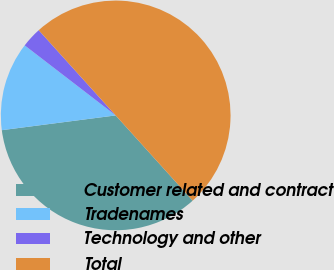Convert chart. <chart><loc_0><loc_0><loc_500><loc_500><pie_chart><fcel>Customer related and contract<fcel>Tradenames<fcel>Technology and other<fcel>Total<nl><fcel>34.64%<fcel>12.49%<fcel>2.87%<fcel>50.0%<nl></chart> 